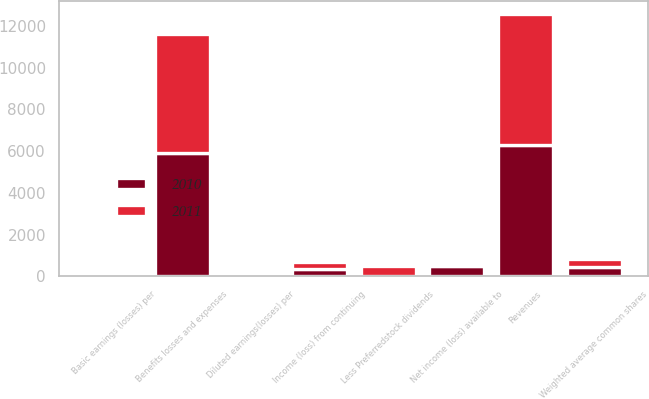Convert chart. <chart><loc_0><loc_0><loc_500><loc_500><stacked_bar_chart><ecel><fcel>Revenues<fcel>Benefits losses and expenses<fcel>Income (loss) from continuing<fcel>Less Preferredstock dividends<fcel>Net income (loss) available to<fcel>Basic earnings (losses) per<fcel>Diluted earnings(losses) per<fcel>Weighted average common shares<nl><fcel>2010<fcel>6308<fcel>5898<fcel>351<fcel>10<fcel>501<fcel>1.13<fcel>1.01<fcel>444.6<nl><fcel>2011<fcel>6257<fcel>5722<fcel>319<fcel>483<fcel>164<fcel>0.42<fcel>0.42<fcel>393.7<nl></chart> 